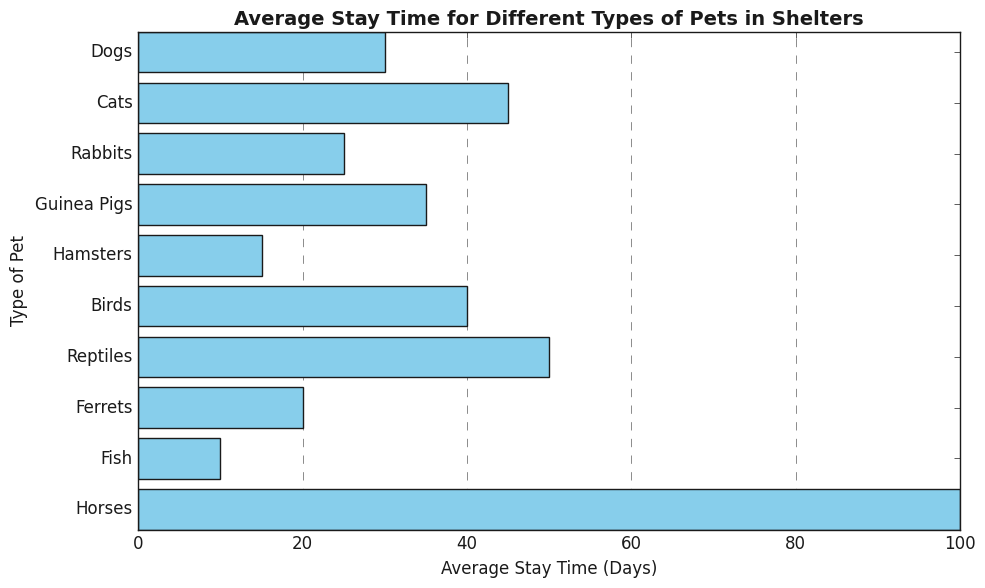Which type of pet has the shortest average stay time in shelters? By looking at the bar chart, we can see which bar is the smallest in length. The bar representing "Fish" is the shortest, indicating the shortest average stay time.
Answer: Fish Which pet type has the longest average stay time in shelters? Observing the chart, the longest bar corresponds to "Horses," indicating they have the longest average stay time.
Answer: Horses Which types of pets have an average stay time that is lower than 30 days? According to the chart, we look for bars that extend below the 30-day mark. These bars correspond to Hamsters, Fish, Ferrets, and Rabbits.
Answer: Hamsters, Fish, Ferrets, Rabbits What is the total average stay time of Cats and Dogs combined? Add the average stay time of Cats (45 days) and Dogs (30 days) from the chart. 45 + 30 = 75
Answer: 75 Which pet type has a shorter stay time, Birds or Guinea Pigs? Compare the bars for Birds and Guinea Pigs. The bar for Guinea Pigs is shorter, indicating a shorter average stay time.
Answer: Guinea Pigs What is the difference in average stay time between Reptiles and Fish? Subtract the average stay time of Fish (10 days) from that of Reptiles (50 days). 50 - 10 = 40
Answer: 40 Which type of pet has an average stay time closest to the median of the listed stay times? First, list the average stay times in ascending order: 10, 15, 20, 25, 30, 35, 40, 45, 50, 100. The median is the middle value, which is 35 days. The pet with an average stay time closest to this is Guinea Pigs.
Answer: Guinea Pigs How many pet types have an average stay time of more than 40 days? Count the bars that extend beyond the 40-day mark. These include Cats, Birds, Reptiles, and Horses, making it four types.
Answer: 4 Among Dogs, Cats, and Rabbits, which has the second shortest average stay time? By comparing the bars for Dogs, Cats, and Rabbits, we see that Dogs have 30 days, Cats have 45 days, and Rabbits have 25 days. The Dog's 30 days is the second shortest.
Answer: Dogs 